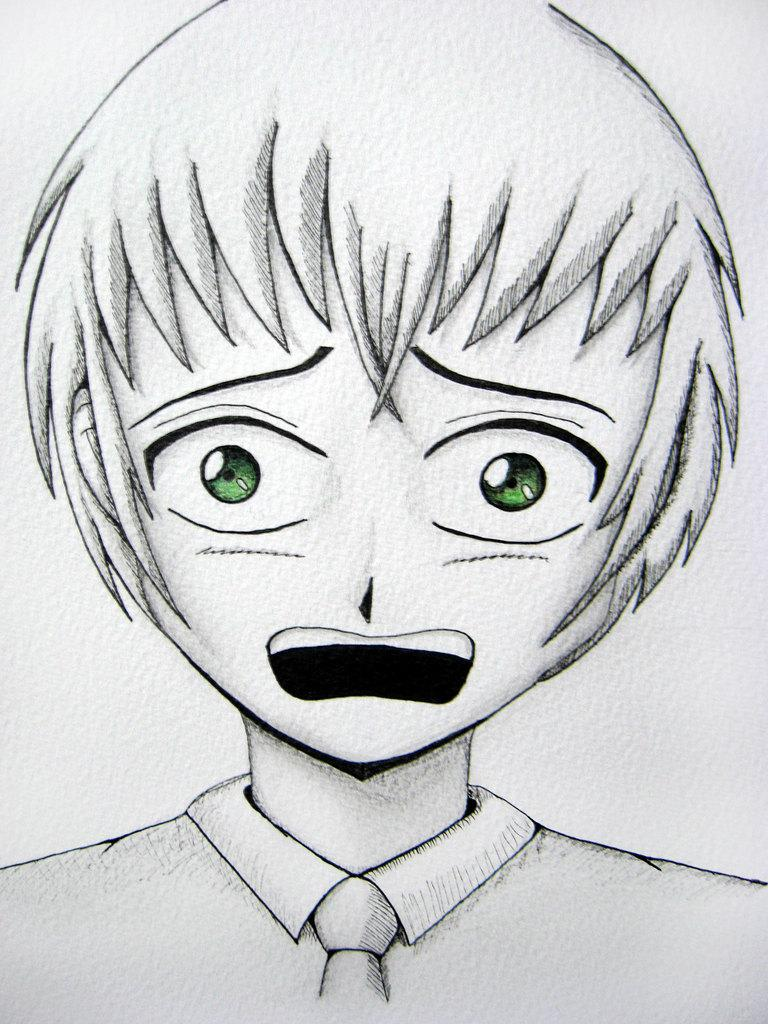What type of artwork is depicted in the image? The image is a sketch. What subject is featured in the sketch? There is a sketch of a boy in the image. What can be observed about the boy's eyes in the sketch? The boy has green eyes. What type of oatmeal is being served to the boy in the image? There is no oatmeal present in the image; it is a sketch of a boy with green eyes. 